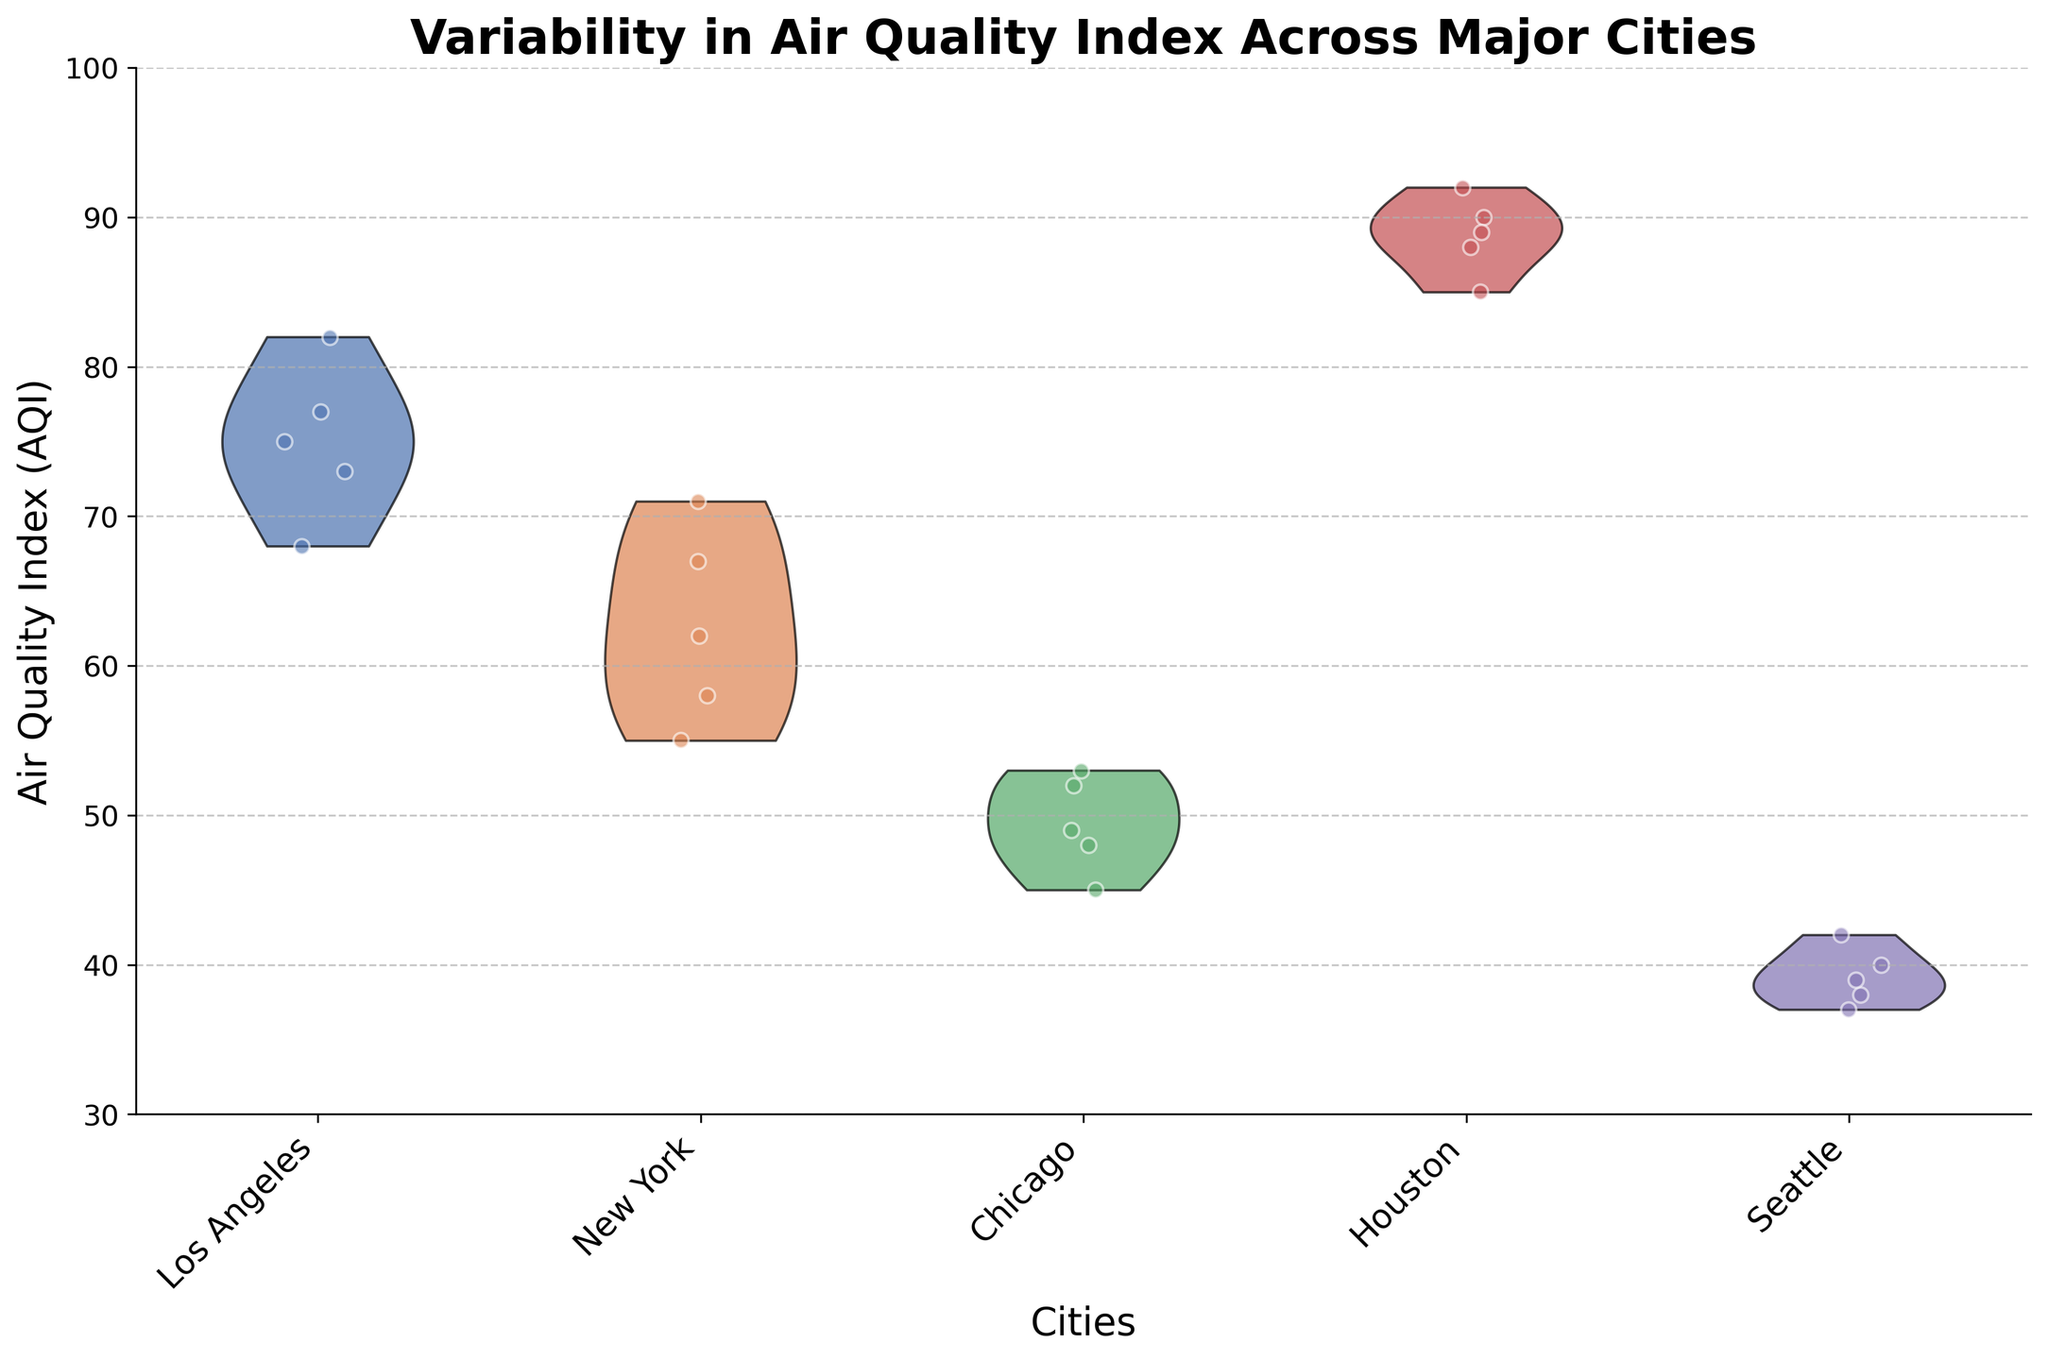what is the title of the figure? The title of the figure is usually located at the top center and in larger, bold font. It gives a summary of what the plot represents.
Answer: Variability in Air Quality Index Across Major Cities How many cities are represented in the plot? By counting the distinct labels on the x-axis, which represent the cities, we can determine this number.
Answer: 5 Which city has the highest median AQI according to the violin plot? The median line is not shown, but the center range of each violin plot can give hints. Observing the plot, Houston's violin plot appears to be the highest.
Answer: Houston What's the range of the AQI values for Seattle? By observing the vertical extent of Seattle's violin plot, we can see the lowest and highest values it reaches. These values give us the range.
Answer: 37 – 42 Which city shows the least variability in AQI? The city with the narrowest violin plot indicates the least variability. Observing the violin plots, Seattle’s plot is the narrowest.
Answer: Seattle Compare the AQI variability between Chicago and Los Angeles. Chicago's violin plot is slightly narrower and shorter than Los Angeles’, indicating it has less variability and lower AQI values overall.
Answer: Chicago has less variability What is the approximate AQI value on September 3rd for New York? The x-axis points for New York are jittered, so looking at the scattered points around the relevant x-value can help identify the specific date's value.
Answer: 71 Which city appears to have the best air quality overall based on the plot? The city with the lowest range and lowest median position of AQI values generally indicates better air quality. Seattle has the lowest values.
Answer: Seattle If you were to visit a city with consistently moderate AQI, which one would you choose based on this plot? Moderate AQI values fall between 51-100. Observing all the violin plots, New York and Chicago fall into this category but New York has higher values.
Answer: Chicago Which city shows the highest AQI on a given day based on the scattered points? By observing the highest scattered points across all cities on the plot, the maximum AQI should be checked.
Answer: Houston 